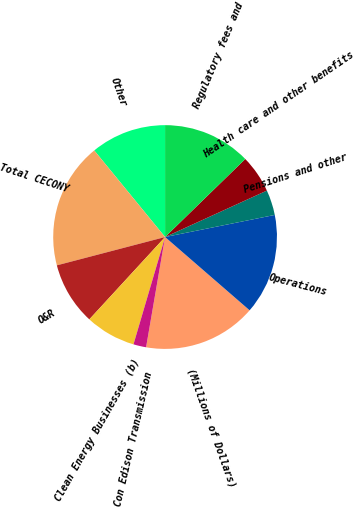<chart> <loc_0><loc_0><loc_500><loc_500><pie_chart><fcel>(Millions of Dollars)<fcel>Operations<fcel>Pensions and other<fcel>Health care and other benefits<fcel>Regulatory fees and<fcel>Other<fcel>Total CECONY<fcel>O&R<fcel>Clean Energy Businesses (b)<fcel>Con Edison Transmission<nl><fcel>16.35%<fcel>14.53%<fcel>3.65%<fcel>5.47%<fcel>12.72%<fcel>10.91%<fcel>18.16%<fcel>9.09%<fcel>7.28%<fcel>1.84%<nl></chart> 